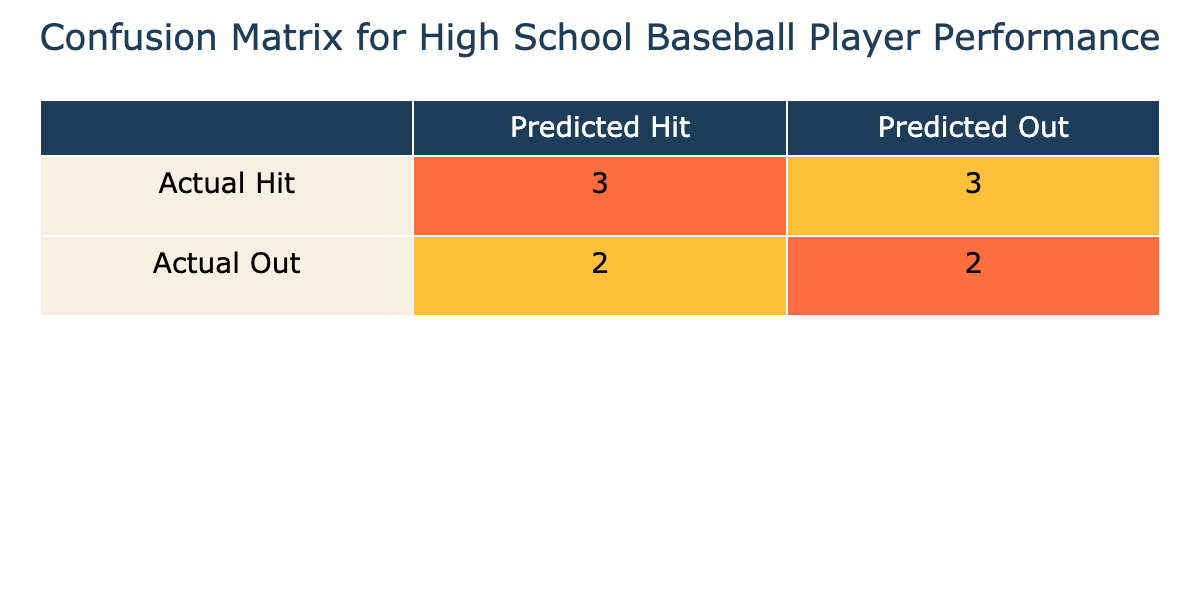What is the total number of players classified as 'Hits'? From the confusion matrix, we see that 'Actual Hit' has 3 players that were predicted as 'Hit'. Adding those up gives us 3.
Answer: 3 What is the total number of players classified as 'Outs'? Looking at the 'Actual Out' row, we see there are 3 players predicted as 'Out'. So the total number of players classified as 'Outs' is 3.
Answer: 3 How many players are predicted correctly overall? The total number of correct predictions is the sum of players classified as 'Hits' (correctly predicted Hits) and as 'Outs' (correctly predicted Outs). From the table, we see there are 3 predicted correctly as 'Hits' and 2 predicted correctly as 'Outs'. So 3 + 2 = 5.
Answer: 5 What percentage of players were predicted as 'Hits'? There are a total of 10 players in the table. The number of players predicted as 'Hits' is 5 (3 correctly predicted Hits and 2 incorrectly predicted). Thus, the percentage is (5/10) * 100 = 50%.
Answer: 50% Is it true that all players who had successful 'Hits' were predicted as 'Hits'? Looking at the table, we see that there are 3 players with actual 'Hits' who were predicted as such (James, Joshua, and Daniel), but Christopher (who had an actual Hit) was predicted as 'Out', so this is false.
Answer: No How many players had actual 'Hits' but were incorrectly predicted as 'Outs'? The relevant row shows that there are 2 players (Christopher and Michael) who had actual hits, but were incorrectly predicted as 'Outs'.
Answer: 1 Which position had the highest number of players predicted correctly? From the table, the positions that had the highest correctly predicted are Outfielder and Catcher, each having 2 players who were predicted correctly.
Answer: Outfielder and Catcher What is the total number of 'Strikeouts' for players predicted as 'Out'? Looking at the table, the players predicted as 'Out' include Michael (5), William (12), Andrew (15), David (11), and Joseph (8). Adding these gives 5 + 12 + 15 + 11 + 8 = 51.
Answer: 51 Which player had the highest number of 'Home Runs' and how many were predicted correctly? James Anderson had the highest number of Home Runs at 5, and he was predicted correctly as 'Hit'.
Answer: James Anderson, 5 